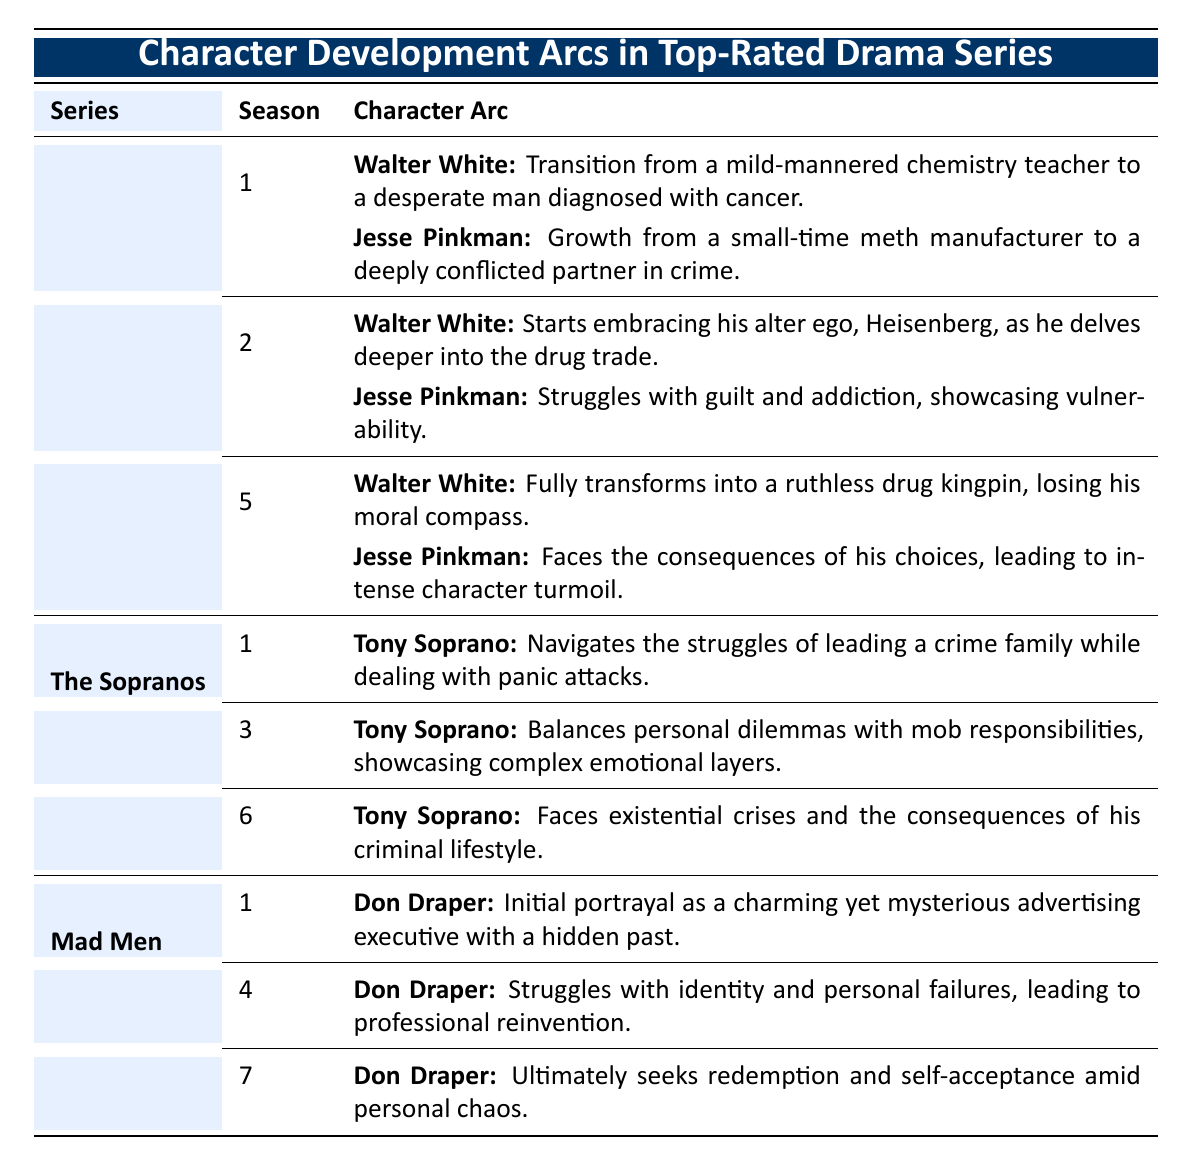What's the character arc of Walter White in Season 1 of Breaking Bad? The table shows that in Season 1, Walter White's arc is described as transitioning from a mild-mannered chemistry teacher to a desperate man diagnosed with cancer.
Answer: Transition from chemistry teacher to desperate man What season features Tony Soprano facing existential crises? The table indicates that Tony Soprano faces existential crises in Season 6 of The Sopranos.
Answer: Season 6 Which character in Mad Men seeks redemption in Season 7? According to the table, Don Draper is the character who ultimately seeks redemption and self-acceptance in Season 7.
Answer: Don Draper How many seasons contribute to the character arc of Jesse Pinkman in Breaking Bad? Jesse Pinkman has character arcs in three seasons: Season 1, Season 2, and Season 5.
Answer: Three seasons True or False: Don Draper's character arc in Season 4 involves struggling with identity and personal failures. The table confirms that in Season 4, Don Draper's arc indeed involves struggles with identity and personal failures.
Answer: True What is the main change in Walter White’s character from Season 1 to Season 5 in Breaking Bad? In Season 1, Walter White transitions from a teacher to a desperate man, while by Season 5, he fully transforms into a ruthless drug kingpin, indicating a loss of his moral compass.
Answer: He transforms into a ruthless drug kingpin Which character in The Sopranos showcases complex emotional layers in Season 3? The table specifies that Tony Soprano showcases complex emotional layers in Season 3.
Answer: Tony Soprano What are the main themes of Don Draper’s character arc across Seasons 1, 4, and 7 in Mad Men? In Season 1, he is portrayed as mysterious; in Season 4, he struggles with identity; and in Season 7, he seeks redemption, showing a progression from mystery to self-acceptance.
Answer: Mystery, identity struggle, redemption 